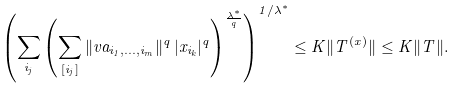Convert formula to latex. <formula><loc_0><loc_0><loc_500><loc_500>\left ( \sum _ { i _ { j } } \left ( \sum _ { [ i _ { j } ] } \| v a _ { i _ { 1 } , \dots , i _ { m } } \| ^ { q } \, | x _ { i _ { k } } | ^ { q } \right ) ^ { \frac { \lambda ^ { * } } { q } } \right ) ^ { 1 / \lambda ^ { * } } \leq K \| T ^ { ( x ) } \| \leq K \| T \| .</formula> 